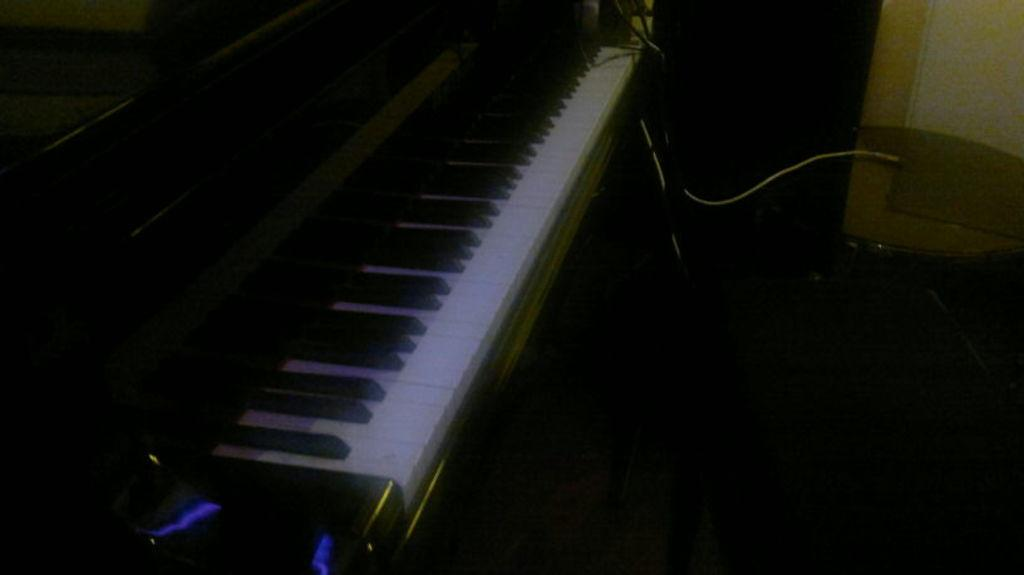What musical instrument is present in the image? There is a piano in the image. What type of object can be seen connected to something else in the image? There is a cable in the image. What type of furniture is present in the image? There is a table in the image. What type of structure is present in the image? There is a wall in the image. What type of wood can be seen growing on the wall in the image? There is no wood growing on the wall in the image. How many cabbages are visible on the table in the image? There are no cabbages present in the image. 